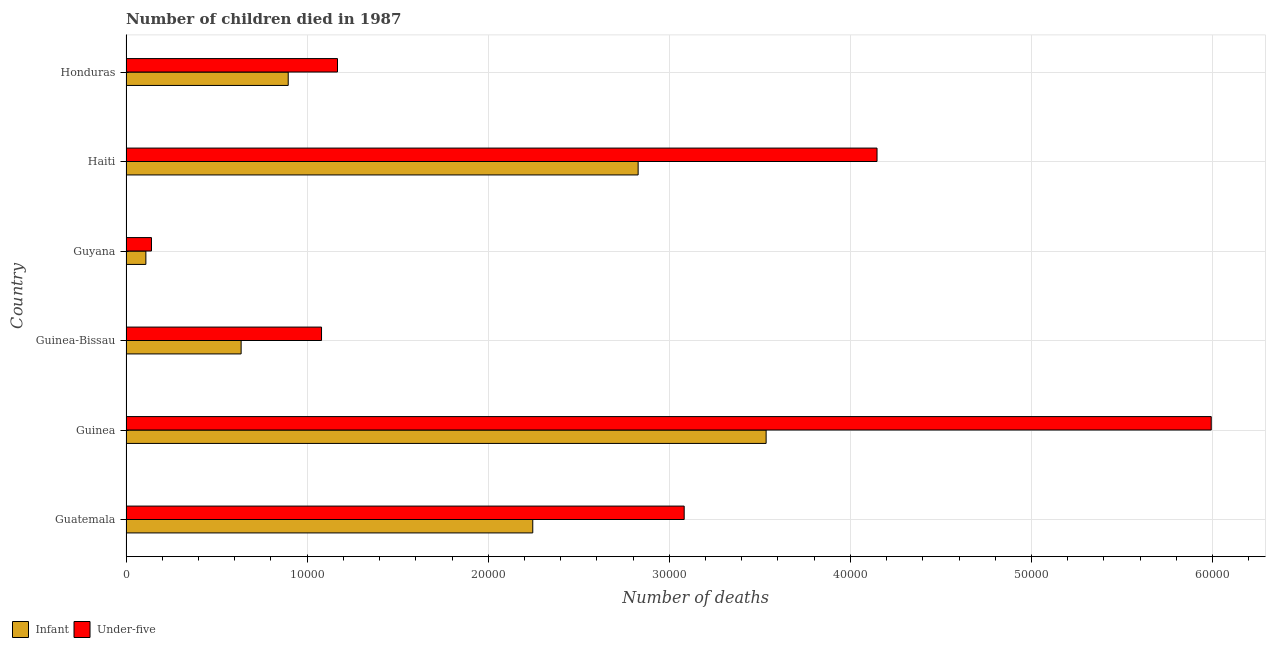How many different coloured bars are there?
Offer a very short reply. 2. How many groups of bars are there?
Provide a succinct answer. 6. Are the number of bars per tick equal to the number of legend labels?
Give a very brief answer. Yes. How many bars are there on the 5th tick from the bottom?
Ensure brevity in your answer.  2. What is the label of the 2nd group of bars from the top?
Offer a very short reply. Haiti. In how many cases, is the number of bars for a given country not equal to the number of legend labels?
Provide a succinct answer. 0. What is the number of infant deaths in Guyana?
Your answer should be very brief. 1097. Across all countries, what is the maximum number of infant deaths?
Offer a terse response. 3.53e+04. Across all countries, what is the minimum number of infant deaths?
Ensure brevity in your answer.  1097. In which country was the number of under-five deaths maximum?
Keep it short and to the point. Guinea. In which country was the number of infant deaths minimum?
Make the answer very short. Guyana. What is the total number of infant deaths in the graph?
Offer a terse response. 1.02e+05. What is the difference between the number of under-five deaths in Guinea-Bissau and that in Honduras?
Offer a terse response. -882. What is the difference between the number of infant deaths in Honduras and the number of under-five deaths in Guyana?
Offer a terse response. 7551. What is the average number of under-five deaths per country?
Ensure brevity in your answer.  2.60e+04. What is the difference between the number of under-five deaths and number of infant deaths in Haiti?
Your answer should be compact. 1.32e+04. In how many countries, is the number of infant deaths greater than 38000 ?
Give a very brief answer. 0. What is the ratio of the number of under-five deaths in Guatemala to that in Guinea?
Your answer should be compact. 0.51. Is the number of under-five deaths in Guinea less than that in Honduras?
Make the answer very short. No. What is the difference between the highest and the second highest number of infant deaths?
Give a very brief answer. 7067. What is the difference between the highest and the lowest number of infant deaths?
Your response must be concise. 3.42e+04. Is the sum of the number of infant deaths in Guatemala and Guinea greater than the maximum number of under-five deaths across all countries?
Provide a short and direct response. No. What does the 2nd bar from the top in Guinea-Bissau represents?
Provide a short and direct response. Infant. What does the 1st bar from the bottom in Guatemala represents?
Your answer should be compact. Infant. How many bars are there?
Offer a terse response. 12. How many countries are there in the graph?
Provide a succinct answer. 6. What is the difference between two consecutive major ticks on the X-axis?
Your response must be concise. 10000. Are the values on the major ticks of X-axis written in scientific E-notation?
Ensure brevity in your answer.  No. Does the graph contain any zero values?
Your answer should be compact. No. Does the graph contain grids?
Provide a short and direct response. Yes. How many legend labels are there?
Offer a very short reply. 2. How are the legend labels stacked?
Give a very brief answer. Horizontal. What is the title of the graph?
Provide a short and direct response. Number of children died in 1987. What is the label or title of the X-axis?
Your response must be concise. Number of deaths. What is the Number of deaths of Infant in Guatemala?
Provide a succinct answer. 2.25e+04. What is the Number of deaths in Under-five in Guatemala?
Provide a short and direct response. 3.08e+04. What is the Number of deaths of Infant in Guinea?
Give a very brief answer. 3.53e+04. What is the Number of deaths of Under-five in Guinea?
Make the answer very short. 5.99e+04. What is the Number of deaths of Infant in Guinea-Bissau?
Your response must be concise. 6356. What is the Number of deaths in Under-five in Guinea-Bissau?
Your response must be concise. 1.08e+04. What is the Number of deaths of Infant in Guyana?
Make the answer very short. 1097. What is the Number of deaths in Under-five in Guyana?
Give a very brief answer. 1406. What is the Number of deaths of Infant in Haiti?
Your answer should be very brief. 2.83e+04. What is the Number of deaths in Under-five in Haiti?
Your answer should be very brief. 4.15e+04. What is the Number of deaths in Infant in Honduras?
Give a very brief answer. 8957. What is the Number of deaths of Under-five in Honduras?
Give a very brief answer. 1.17e+04. Across all countries, what is the maximum Number of deaths in Infant?
Give a very brief answer. 3.53e+04. Across all countries, what is the maximum Number of deaths of Under-five?
Your answer should be compact. 5.99e+04. Across all countries, what is the minimum Number of deaths of Infant?
Keep it short and to the point. 1097. Across all countries, what is the minimum Number of deaths of Under-five?
Give a very brief answer. 1406. What is the total Number of deaths in Infant in the graph?
Ensure brevity in your answer.  1.02e+05. What is the total Number of deaths of Under-five in the graph?
Ensure brevity in your answer.  1.56e+05. What is the difference between the Number of deaths of Infant in Guatemala and that in Guinea?
Keep it short and to the point. -1.29e+04. What is the difference between the Number of deaths of Under-five in Guatemala and that in Guinea?
Keep it short and to the point. -2.91e+04. What is the difference between the Number of deaths of Infant in Guatemala and that in Guinea-Bissau?
Ensure brevity in your answer.  1.61e+04. What is the difference between the Number of deaths in Under-five in Guatemala and that in Guinea-Bissau?
Give a very brief answer. 2.00e+04. What is the difference between the Number of deaths of Infant in Guatemala and that in Guyana?
Provide a succinct answer. 2.14e+04. What is the difference between the Number of deaths in Under-five in Guatemala and that in Guyana?
Offer a terse response. 2.94e+04. What is the difference between the Number of deaths of Infant in Guatemala and that in Haiti?
Your response must be concise. -5818. What is the difference between the Number of deaths of Under-five in Guatemala and that in Haiti?
Offer a terse response. -1.06e+04. What is the difference between the Number of deaths of Infant in Guatemala and that in Honduras?
Offer a very short reply. 1.35e+04. What is the difference between the Number of deaths in Under-five in Guatemala and that in Honduras?
Keep it short and to the point. 1.91e+04. What is the difference between the Number of deaths in Infant in Guinea and that in Guinea-Bissau?
Keep it short and to the point. 2.90e+04. What is the difference between the Number of deaths of Under-five in Guinea and that in Guinea-Bissau?
Offer a very short reply. 4.91e+04. What is the difference between the Number of deaths in Infant in Guinea and that in Guyana?
Keep it short and to the point. 3.42e+04. What is the difference between the Number of deaths in Under-five in Guinea and that in Guyana?
Provide a short and direct response. 5.85e+04. What is the difference between the Number of deaths of Infant in Guinea and that in Haiti?
Offer a terse response. 7067. What is the difference between the Number of deaths in Under-five in Guinea and that in Haiti?
Keep it short and to the point. 1.85e+04. What is the difference between the Number of deaths in Infant in Guinea and that in Honduras?
Your response must be concise. 2.64e+04. What is the difference between the Number of deaths in Under-five in Guinea and that in Honduras?
Provide a succinct answer. 4.82e+04. What is the difference between the Number of deaths of Infant in Guinea-Bissau and that in Guyana?
Give a very brief answer. 5259. What is the difference between the Number of deaths of Under-five in Guinea-Bissau and that in Guyana?
Make the answer very short. 9390. What is the difference between the Number of deaths of Infant in Guinea-Bissau and that in Haiti?
Offer a terse response. -2.19e+04. What is the difference between the Number of deaths in Under-five in Guinea-Bissau and that in Haiti?
Ensure brevity in your answer.  -3.07e+04. What is the difference between the Number of deaths in Infant in Guinea-Bissau and that in Honduras?
Ensure brevity in your answer.  -2601. What is the difference between the Number of deaths in Under-five in Guinea-Bissau and that in Honduras?
Offer a very short reply. -882. What is the difference between the Number of deaths in Infant in Guyana and that in Haiti?
Give a very brief answer. -2.72e+04. What is the difference between the Number of deaths in Under-five in Guyana and that in Haiti?
Give a very brief answer. -4.01e+04. What is the difference between the Number of deaths in Infant in Guyana and that in Honduras?
Provide a short and direct response. -7860. What is the difference between the Number of deaths in Under-five in Guyana and that in Honduras?
Ensure brevity in your answer.  -1.03e+04. What is the difference between the Number of deaths of Infant in Haiti and that in Honduras?
Provide a short and direct response. 1.93e+04. What is the difference between the Number of deaths in Under-five in Haiti and that in Honduras?
Make the answer very short. 2.98e+04. What is the difference between the Number of deaths in Infant in Guatemala and the Number of deaths in Under-five in Guinea?
Offer a terse response. -3.75e+04. What is the difference between the Number of deaths of Infant in Guatemala and the Number of deaths of Under-five in Guinea-Bissau?
Your answer should be compact. 1.17e+04. What is the difference between the Number of deaths of Infant in Guatemala and the Number of deaths of Under-five in Guyana?
Offer a very short reply. 2.11e+04. What is the difference between the Number of deaths of Infant in Guatemala and the Number of deaths of Under-five in Haiti?
Your answer should be very brief. -1.90e+04. What is the difference between the Number of deaths in Infant in Guatemala and the Number of deaths in Under-five in Honduras?
Make the answer very short. 1.08e+04. What is the difference between the Number of deaths in Infant in Guinea and the Number of deaths in Under-five in Guinea-Bissau?
Your answer should be compact. 2.45e+04. What is the difference between the Number of deaths of Infant in Guinea and the Number of deaths of Under-five in Guyana?
Offer a very short reply. 3.39e+04. What is the difference between the Number of deaths in Infant in Guinea and the Number of deaths in Under-five in Haiti?
Offer a terse response. -6124. What is the difference between the Number of deaths in Infant in Guinea and the Number of deaths in Under-five in Honduras?
Offer a terse response. 2.37e+04. What is the difference between the Number of deaths in Infant in Guinea-Bissau and the Number of deaths in Under-five in Guyana?
Keep it short and to the point. 4950. What is the difference between the Number of deaths in Infant in Guinea-Bissau and the Number of deaths in Under-five in Haiti?
Give a very brief answer. -3.51e+04. What is the difference between the Number of deaths of Infant in Guinea-Bissau and the Number of deaths of Under-five in Honduras?
Ensure brevity in your answer.  -5322. What is the difference between the Number of deaths of Infant in Guyana and the Number of deaths of Under-five in Haiti?
Offer a terse response. -4.04e+04. What is the difference between the Number of deaths in Infant in Guyana and the Number of deaths in Under-five in Honduras?
Your answer should be very brief. -1.06e+04. What is the difference between the Number of deaths in Infant in Haiti and the Number of deaths in Under-five in Honduras?
Your answer should be compact. 1.66e+04. What is the average Number of deaths in Infant per country?
Offer a very short reply. 1.71e+04. What is the average Number of deaths of Under-five per country?
Keep it short and to the point. 2.60e+04. What is the difference between the Number of deaths in Infant and Number of deaths in Under-five in Guatemala?
Your answer should be very brief. -8361. What is the difference between the Number of deaths of Infant and Number of deaths of Under-five in Guinea?
Provide a short and direct response. -2.46e+04. What is the difference between the Number of deaths of Infant and Number of deaths of Under-five in Guinea-Bissau?
Offer a very short reply. -4440. What is the difference between the Number of deaths of Infant and Number of deaths of Under-five in Guyana?
Provide a short and direct response. -309. What is the difference between the Number of deaths of Infant and Number of deaths of Under-five in Haiti?
Provide a succinct answer. -1.32e+04. What is the difference between the Number of deaths of Infant and Number of deaths of Under-five in Honduras?
Ensure brevity in your answer.  -2721. What is the ratio of the Number of deaths of Infant in Guatemala to that in Guinea?
Give a very brief answer. 0.64. What is the ratio of the Number of deaths of Under-five in Guatemala to that in Guinea?
Give a very brief answer. 0.51. What is the ratio of the Number of deaths in Infant in Guatemala to that in Guinea-Bissau?
Provide a short and direct response. 3.53. What is the ratio of the Number of deaths of Under-five in Guatemala to that in Guinea-Bissau?
Provide a succinct answer. 2.85. What is the ratio of the Number of deaths in Infant in Guatemala to that in Guyana?
Your answer should be compact. 20.47. What is the ratio of the Number of deaths of Under-five in Guatemala to that in Guyana?
Offer a very short reply. 21.92. What is the ratio of the Number of deaths in Infant in Guatemala to that in Haiti?
Your answer should be compact. 0.79. What is the ratio of the Number of deaths in Under-five in Guatemala to that in Haiti?
Make the answer very short. 0.74. What is the ratio of the Number of deaths in Infant in Guatemala to that in Honduras?
Your response must be concise. 2.51. What is the ratio of the Number of deaths of Under-five in Guatemala to that in Honduras?
Offer a terse response. 2.64. What is the ratio of the Number of deaths in Infant in Guinea to that in Guinea-Bissau?
Ensure brevity in your answer.  5.56. What is the ratio of the Number of deaths in Under-five in Guinea to that in Guinea-Bissau?
Provide a succinct answer. 5.55. What is the ratio of the Number of deaths in Infant in Guinea to that in Guyana?
Offer a terse response. 32.22. What is the ratio of the Number of deaths of Under-five in Guinea to that in Guyana?
Ensure brevity in your answer.  42.62. What is the ratio of the Number of deaths of Infant in Guinea to that in Haiti?
Your answer should be compact. 1.25. What is the ratio of the Number of deaths of Under-five in Guinea to that in Haiti?
Your answer should be very brief. 1.45. What is the ratio of the Number of deaths of Infant in Guinea to that in Honduras?
Offer a very short reply. 3.95. What is the ratio of the Number of deaths in Under-five in Guinea to that in Honduras?
Give a very brief answer. 5.13. What is the ratio of the Number of deaths in Infant in Guinea-Bissau to that in Guyana?
Offer a very short reply. 5.79. What is the ratio of the Number of deaths of Under-five in Guinea-Bissau to that in Guyana?
Your answer should be compact. 7.68. What is the ratio of the Number of deaths of Infant in Guinea-Bissau to that in Haiti?
Offer a very short reply. 0.22. What is the ratio of the Number of deaths of Under-five in Guinea-Bissau to that in Haiti?
Offer a very short reply. 0.26. What is the ratio of the Number of deaths in Infant in Guinea-Bissau to that in Honduras?
Your response must be concise. 0.71. What is the ratio of the Number of deaths of Under-five in Guinea-Bissau to that in Honduras?
Your response must be concise. 0.92. What is the ratio of the Number of deaths in Infant in Guyana to that in Haiti?
Give a very brief answer. 0.04. What is the ratio of the Number of deaths of Under-five in Guyana to that in Haiti?
Your answer should be compact. 0.03. What is the ratio of the Number of deaths of Infant in Guyana to that in Honduras?
Your answer should be very brief. 0.12. What is the ratio of the Number of deaths of Under-five in Guyana to that in Honduras?
Your answer should be compact. 0.12. What is the ratio of the Number of deaths of Infant in Haiti to that in Honduras?
Provide a short and direct response. 3.16. What is the ratio of the Number of deaths in Under-five in Haiti to that in Honduras?
Offer a very short reply. 3.55. What is the difference between the highest and the second highest Number of deaths of Infant?
Offer a terse response. 7067. What is the difference between the highest and the second highest Number of deaths in Under-five?
Your answer should be very brief. 1.85e+04. What is the difference between the highest and the lowest Number of deaths of Infant?
Give a very brief answer. 3.42e+04. What is the difference between the highest and the lowest Number of deaths of Under-five?
Make the answer very short. 5.85e+04. 